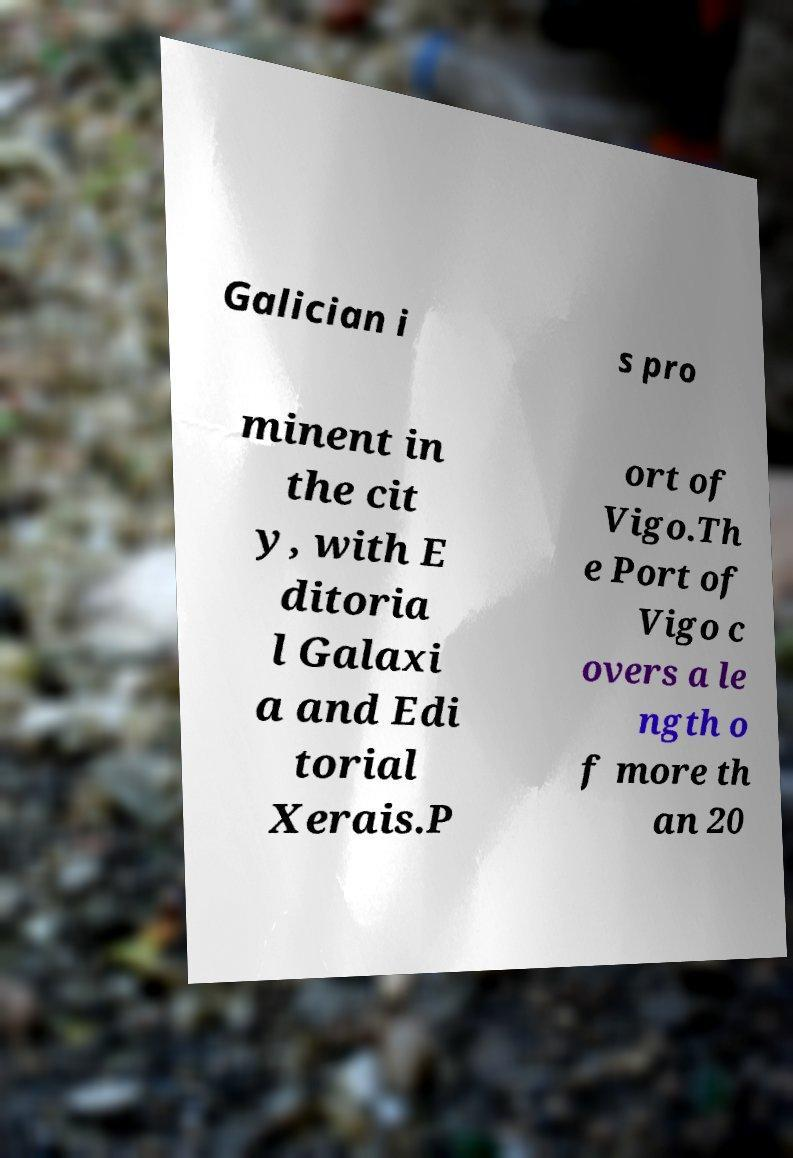There's text embedded in this image that I need extracted. Can you transcribe it verbatim? Galician i s pro minent in the cit y, with E ditoria l Galaxi a and Edi torial Xerais.P ort of Vigo.Th e Port of Vigo c overs a le ngth o f more th an 20 